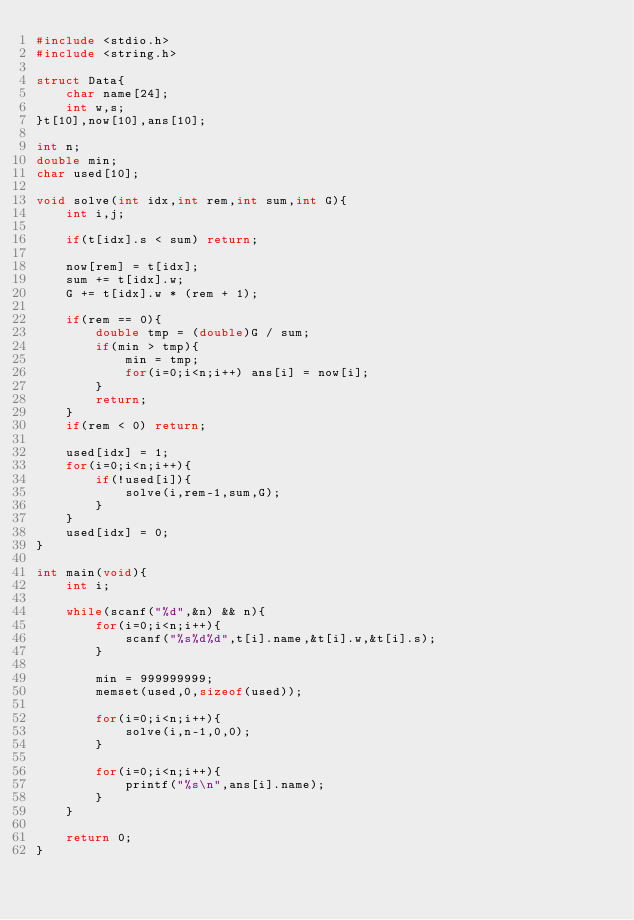<code> <loc_0><loc_0><loc_500><loc_500><_C_>#include <stdio.h>
#include <string.h>

struct Data{
	char name[24];
	int w,s;
}t[10],now[10],ans[10];

int n;
double min;
char used[10];

void solve(int idx,int rem,int sum,int G){
	int i,j;

	if(t[idx].s < sum) return;

	now[rem] = t[idx];
	sum += t[idx].w;
	G += t[idx].w * (rem + 1);

	if(rem == 0){
		double tmp = (double)G / sum;
		if(min > tmp){
			min = tmp;
			for(i=0;i<n;i++) ans[i] = now[i];
		}
		return;
	}
	if(rem < 0) return;

	used[idx] = 1;
	for(i=0;i<n;i++){
		if(!used[i]){
			solve(i,rem-1,sum,G);
		}
	}
	used[idx] = 0;
}

int main(void){
	int i;

	while(scanf("%d",&n) && n){
		for(i=0;i<n;i++){
			scanf("%s%d%d",t[i].name,&t[i].w,&t[i].s);
		}

		min = 999999999;
		memset(used,0,sizeof(used));

		for(i=0;i<n;i++){
			solve(i,n-1,0,0);
		}

		for(i=0;i<n;i++){
			printf("%s\n",ans[i].name);
		}
	}

	return 0;
}</code> 